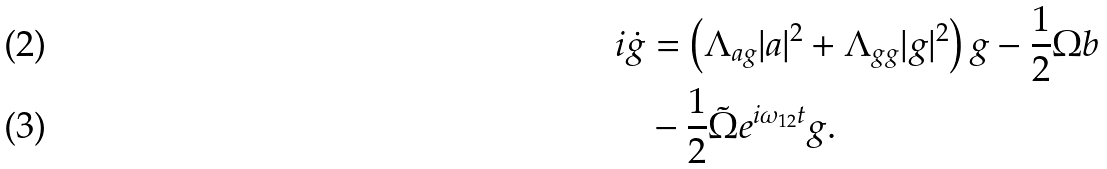Convert formula to latex. <formula><loc_0><loc_0><loc_500><loc_500>i \dot { g } & = \left ( \Lambda _ { a g } | a | ^ { 2 } + \Lambda _ { g g } | g | ^ { 2 } \right ) g - \frac { 1 } { 2 } \Omega b \\ & - \frac { 1 } { 2 } \tilde { \Omega } e ^ { i \omega _ { 1 2 } t } g .</formula> 